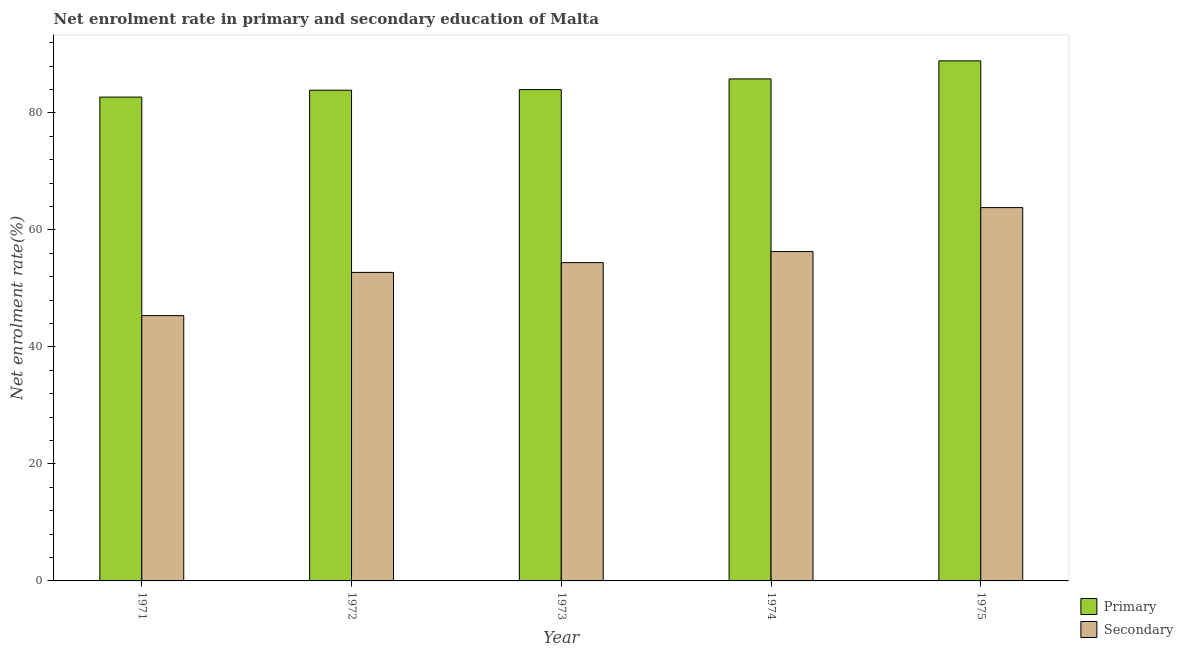Are the number of bars on each tick of the X-axis equal?
Offer a very short reply. Yes. How many bars are there on the 3rd tick from the left?
Give a very brief answer. 2. How many bars are there on the 2nd tick from the right?
Offer a terse response. 2. What is the label of the 3rd group of bars from the left?
Offer a very short reply. 1973. What is the enrollment rate in secondary education in 1973?
Your answer should be compact. 54.41. Across all years, what is the maximum enrollment rate in primary education?
Your response must be concise. 88.9. Across all years, what is the minimum enrollment rate in primary education?
Your response must be concise. 82.71. In which year was the enrollment rate in primary education maximum?
Offer a terse response. 1975. What is the total enrollment rate in primary education in the graph?
Give a very brief answer. 425.32. What is the difference between the enrollment rate in primary education in 1972 and that in 1973?
Your answer should be very brief. -0.1. What is the difference between the enrollment rate in primary education in 1973 and the enrollment rate in secondary education in 1972?
Provide a short and direct response. 0.1. What is the average enrollment rate in secondary education per year?
Ensure brevity in your answer.  54.53. In how many years, is the enrollment rate in secondary education greater than 64 %?
Offer a very short reply. 0. What is the ratio of the enrollment rate in secondary education in 1971 to that in 1973?
Offer a terse response. 0.83. What is the difference between the highest and the second highest enrollment rate in secondary education?
Offer a very short reply. 7.51. What is the difference between the highest and the lowest enrollment rate in secondary education?
Keep it short and to the point. 18.47. What does the 1st bar from the left in 1971 represents?
Ensure brevity in your answer.  Primary. What does the 2nd bar from the right in 1974 represents?
Your answer should be very brief. Primary. How many bars are there?
Give a very brief answer. 10. Does the graph contain any zero values?
Your answer should be compact. No. Does the graph contain grids?
Offer a very short reply. No. Where does the legend appear in the graph?
Your answer should be compact. Bottom right. What is the title of the graph?
Provide a succinct answer. Net enrolment rate in primary and secondary education of Malta. Does "Primary education" appear as one of the legend labels in the graph?
Provide a succinct answer. No. What is the label or title of the X-axis?
Ensure brevity in your answer.  Year. What is the label or title of the Y-axis?
Keep it short and to the point. Net enrolment rate(%). What is the Net enrolment rate(%) in Primary in 1971?
Provide a short and direct response. 82.71. What is the Net enrolment rate(%) of Secondary in 1971?
Your answer should be compact. 45.35. What is the Net enrolment rate(%) of Primary in 1972?
Offer a terse response. 83.89. What is the Net enrolment rate(%) of Secondary in 1972?
Your response must be concise. 52.74. What is the Net enrolment rate(%) in Primary in 1973?
Provide a succinct answer. 83.99. What is the Net enrolment rate(%) of Secondary in 1973?
Ensure brevity in your answer.  54.41. What is the Net enrolment rate(%) in Primary in 1974?
Provide a short and direct response. 85.82. What is the Net enrolment rate(%) of Secondary in 1974?
Offer a terse response. 56.3. What is the Net enrolment rate(%) in Primary in 1975?
Offer a very short reply. 88.9. What is the Net enrolment rate(%) of Secondary in 1975?
Your answer should be compact. 63.82. Across all years, what is the maximum Net enrolment rate(%) of Primary?
Your answer should be compact. 88.9. Across all years, what is the maximum Net enrolment rate(%) in Secondary?
Provide a short and direct response. 63.82. Across all years, what is the minimum Net enrolment rate(%) of Primary?
Your answer should be compact. 82.71. Across all years, what is the minimum Net enrolment rate(%) in Secondary?
Keep it short and to the point. 45.35. What is the total Net enrolment rate(%) in Primary in the graph?
Offer a terse response. 425.32. What is the total Net enrolment rate(%) of Secondary in the graph?
Offer a terse response. 272.64. What is the difference between the Net enrolment rate(%) of Primary in 1971 and that in 1972?
Offer a terse response. -1.18. What is the difference between the Net enrolment rate(%) of Secondary in 1971 and that in 1972?
Your answer should be compact. -7.39. What is the difference between the Net enrolment rate(%) in Primary in 1971 and that in 1973?
Ensure brevity in your answer.  -1.28. What is the difference between the Net enrolment rate(%) in Secondary in 1971 and that in 1973?
Keep it short and to the point. -9.06. What is the difference between the Net enrolment rate(%) in Primary in 1971 and that in 1974?
Provide a short and direct response. -3.11. What is the difference between the Net enrolment rate(%) in Secondary in 1971 and that in 1974?
Offer a very short reply. -10.95. What is the difference between the Net enrolment rate(%) of Primary in 1971 and that in 1975?
Make the answer very short. -6.19. What is the difference between the Net enrolment rate(%) of Secondary in 1971 and that in 1975?
Make the answer very short. -18.47. What is the difference between the Net enrolment rate(%) in Primary in 1972 and that in 1973?
Give a very brief answer. -0.1. What is the difference between the Net enrolment rate(%) of Secondary in 1972 and that in 1973?
Make the answer very short. -1.67. What is the difference between the Net enrolment rate(%) of Primary in 1972 and that in 1974?
Your response must be concise. -1.93. What is the difference between the Net enrolment rate(%) in Secondary in 1972 and that in 1974?
Ensure brevity in your answer.  -3.56. What is the difference between the Net enrolment rate(%) of Primary in 1972 and that in 1975?
Your response must be concise. -5.01. What is the difference between the Net enrolment rate(%) in Secondary in 1972 and that in 1975?
Give a very brief answer. -11.08. What is the difference between the Net enrolment rate(%) in Primary in 1973 and that in 1974?
Offer a very short reply. -1.83. What is the difference between the Net enrolment rate(%) of Secondary in 1973 and that in 1974?
Ensure brevity in your answer.  -1.89. What is the difference between the Net enrolment rate(%) in Primary in 1973 and that in 1975?
Provide a succinct answer. -4.91. What is the difference between the Net enrolment rate(%) of Secondary in 1973 and that in 1975?
Your answer should be very brief. -9.41. What is the difference between the Net enrolment rate(%) of Primary in 1974 and that in 1975?
Make the answer very short. -3.08. What is the difference between the Net enrolment rate(%) of Secondary in 1974 and that in 1975?
Give a very brief answer. -7.51. What is the difference between the Net enrolment rate(%) in Primary in 1971 and the Net enrolment rate(%) in Secondary in 1972?
Offer a terse response. 29.97. What is the difference between the Net enrolment rate(%) of Primary in 1971 and the Net enrolment rate(%) of Secondary in 1973?
Your response must be concise. 28.3. What is the difference between the Net enrolment rate(%) in Primary in 1971 and the Net enrolment rate(%) in Secondary in 1974?
Your response must be concise. 26.41. What is the difference between the Net enrolment rate(%) of Primary in 1971 and the Net enrolment rate(%) of Secondary in 1975?
Give a very brief answer. 18.89. What is the difference between the Net enrolment rate(%) in Primary in 1972 and the Net enrolment rate(%) in Secondary in 1973?
Your answer should be compact. 29.48. What is the difference between the Net enrolment rate(%) in Primary in 1972 and the Net enrolment rate(%) in Secondary in 1974?
Give a very brief answer. 27.59. What is the difference between the Net enrolment rate(%) of Primary in 1972 and the Net enrolment rate(%) of Secondary in 1975?
Provide a succinct answer. 20.07. What is the difference between the Net enrolment rate(%) of Primary in 1973 and the Net enrolment rate(%) of Secondary in 1974?
Offer a very short reply. 27.69. What is the difference between the Net enrolment rate(%) in Primary in 1973 and the Net enrolment rate(%) in Secondary in 1975?
Offer a very short reply. 20.18. What is the difference between the Net enrolment rate(%) of Primary in 1974 and the Net enrolment rate(%) of Secondary in 1975?
Make the answer very short. 22. What is the average Net enrolment rate(%) of Primary per year?
Your answer should be very brief. 85.06. What is the average Net enrolment rate(%) in Secondary per year?
Ensure brevity in your answer.  54.53. In the year 1971, what is the difference between the Net enrolment rate(%) in Primary and Net enrolment rate(%) in Secondary?
Ensure brevity in your answer.  37.36. In the year 1972, what is the difference between the Net enrolment rate(%) of Primary and Net enrolment rate(%) of Secondary?
Keep it short and to the point. 31.15. In the year 1973, what is the difference between the Net enrolment rate(%) of Primary and Net enrolment rate(%) of Secondary?
Ensure brevity in your answer.  29.58. In the year 1974, what is the difference between the Net enrolment rate(%) in Primary and Net enrolment rate(%) in Secondary?
Offer a very short reply. 29.52. In the year 1975, what is the difference between the Net enrolment rate(%) of Primary and Net enrolment rate(%) of Secondary?
Keep it short and to the point. 25.08. What is the ratio of the Net enrolment rate(%) in Primary in 1971 to that in 1972?
Provide a succinct answer. 0.99. What is the ratio of the Net enrolment rate(%) in Secondary in 1971 to that in 1972?
Provide a succinct answer. 0.86. What is the ratio of the Net enrolment rate(%) of Primary in 1971 to that in 1973?
Make the answer very short. 0.98. What is the ratio of the Net enrolment rate(%) in Secondary in 1971 to that in 1973?
Keep it short and to the point. 0.83. What is the ratio of the Net enrolment rate(%) in Primary in 1971 to that in 1974?
Provide a short and direct response. 0.96. What is the ratio of the Net enrolment rate(%) in Secondary in 1971 to that in 1974?
Your answer should be compact. 0.81. What is the ratio of the Net enrolment rate(%) in Primary in 1971 to that in 1975?
Provide a succinct answer. 0.93. What is the ratio of the Net enrolment rate(%) in Secondary in 1971 to that in 1975?
Offer a terse response. 0.71. What is the ratio of the Net enrolment rate(%) in Primary in 1972 to that in 1973?
Keep it short and to the point. 1. What is the ratio of the Net enrolment rate(%) of Secondary in 1972 to that in 1973?
Give a very brief answer. 0.97. What is the ratio of the Net enrolment rate(%) of Primary in 1972 to that in 1974?
Keep it short and to the point. 0.98. What is the ratio of the Net enrolment rate(%) of Secondary in 1972 to that in 1974?
Offer a terse response. 0.94. What is the ratio of the Net enrolment rate(%) of Primary in 1972 to that in 1975?
Your answer should be very brief. 0.94. What is the ratio of the Net enrolment rate(%) of Secondary in 1972 to that in 1975?
Your answer should be compact. 0.83. What is the ratio of the Net enrolment rate(%) in Primary in 1973 to that in 1974?
Your answer should be compact. 0.98. What is the ratio of the Net enrolment rate(%) in Secondary in 1973 to that in 1974?
Your response must be concise. 0.97. What is the ratio of the Net enrolment rate(%) of Primary in 1973 to that in 1975?
Provide a short and direct response. 0.94. What is the ratio of the Net enrolment rate(%) in Secondary in 1973 to that in 1975?
Offer a terse response. 0.85. What is the ratio of the Net enrolment rate(%) of Primary in 1974 to that in 1975?
Offer a terse response. 0.97. What is the ratio of the Net enrolment rate(%) of Secondary in 1974 to that in 1975?
Provide a succinct answer. 0.88. What is the difference between the highest and the second highest Net enrolment rate(%) in Primary?
Offer a terse response. 3.08. What is the difference between the highest and the second highest Net enrolment rate(%) of Secondary?
Provide a succinct answer. 7.51. What is the difference between the highest and the lowest Net enrolment rate(%) in Primary?
Provide a succinct answer. 6.19. What is the difference between the highest and the lowest Net enrolment rate(%) of Secondary?
Offer a very short reply. 18.47. 